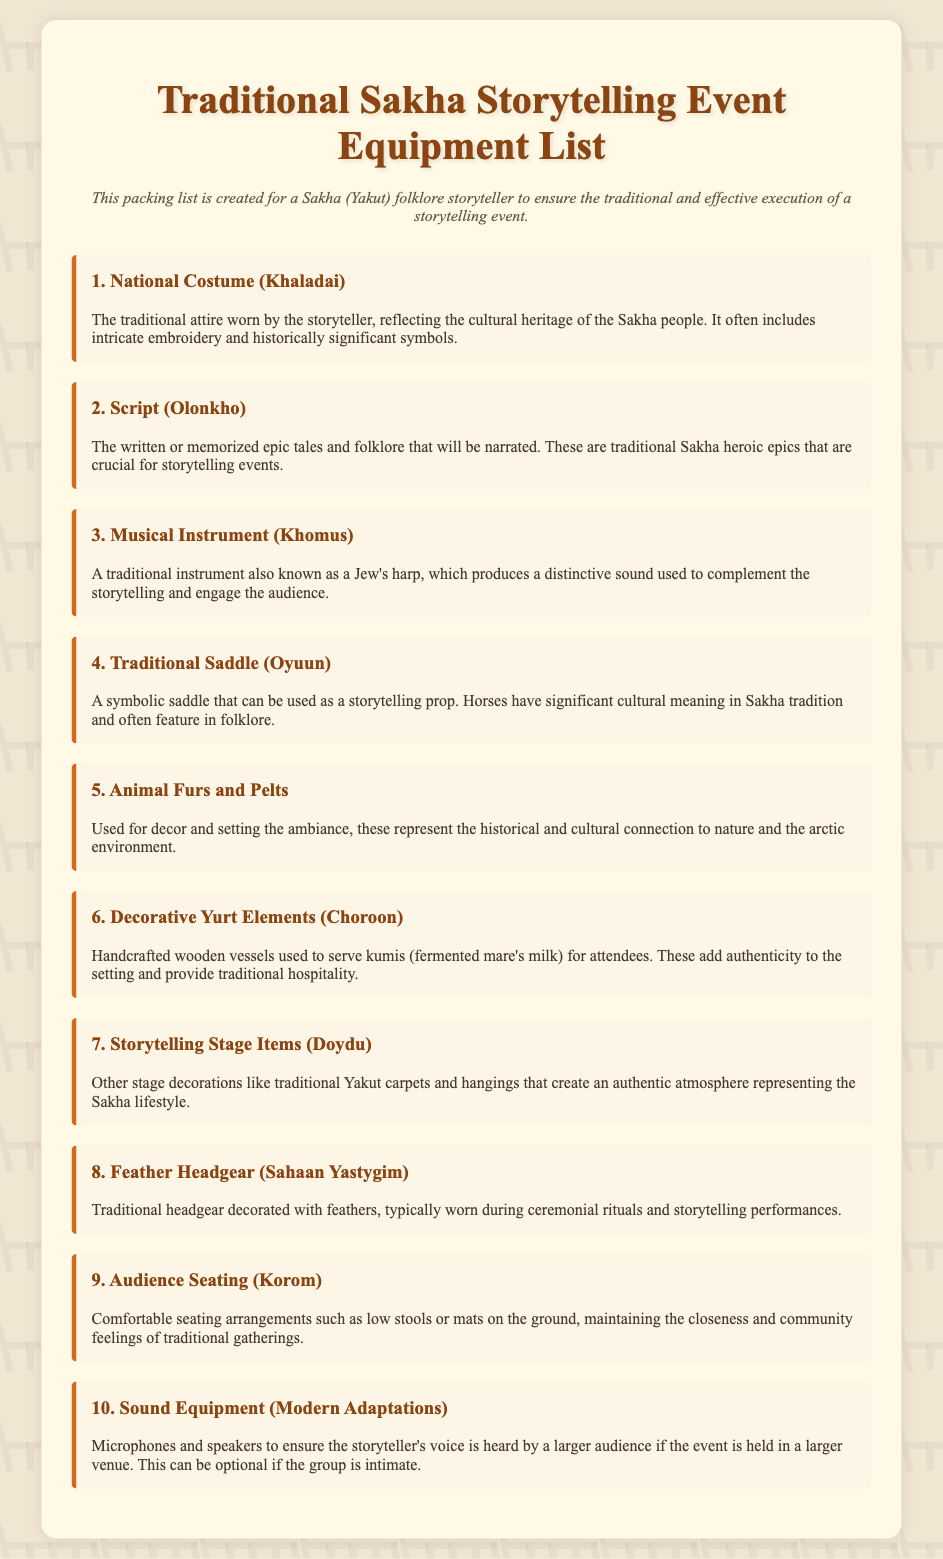What is the first item on the packing list? The first item listed in the document is the National Costume (Khaladai).
Answer: National Costume (Khaladai) What is a Khomus? The Khomus is described as a traditional instrument, also known as a Jew's harp, used during storytelling.
Answer: Jew's harp How many decorative elements are mentioned in the list? There are three decorative elements mentioned: Traditional Saddle (Oyuun), Animal Furs and Pelts, and Decorative Yurt Elements (Choroon).
Answer: Three What is the purpose of the Feather Headgear (Sahaan Yastygim)? The Feather Headgear is typically worn during ceremonial rituals and storytelling performances.
Answer: Ceremonial rituals What type of audience seating is suggested in the list? The recommended audience seating includes comfortable arrangements like low stools or mats.
Answer: Low stools or mats What optional equipment is mentioned for larger venues? The document mentions sound equipment such as microphones and speakers as optional for larger venues.
Answer: Microphones and speakers 